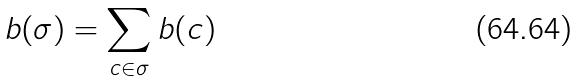Convert formula to latex. <formula><loc_0><loc_0><loc_500><loc_500>b ( \sigma ) = \sum _ { c \in \sigma } b ( c )</formula> 